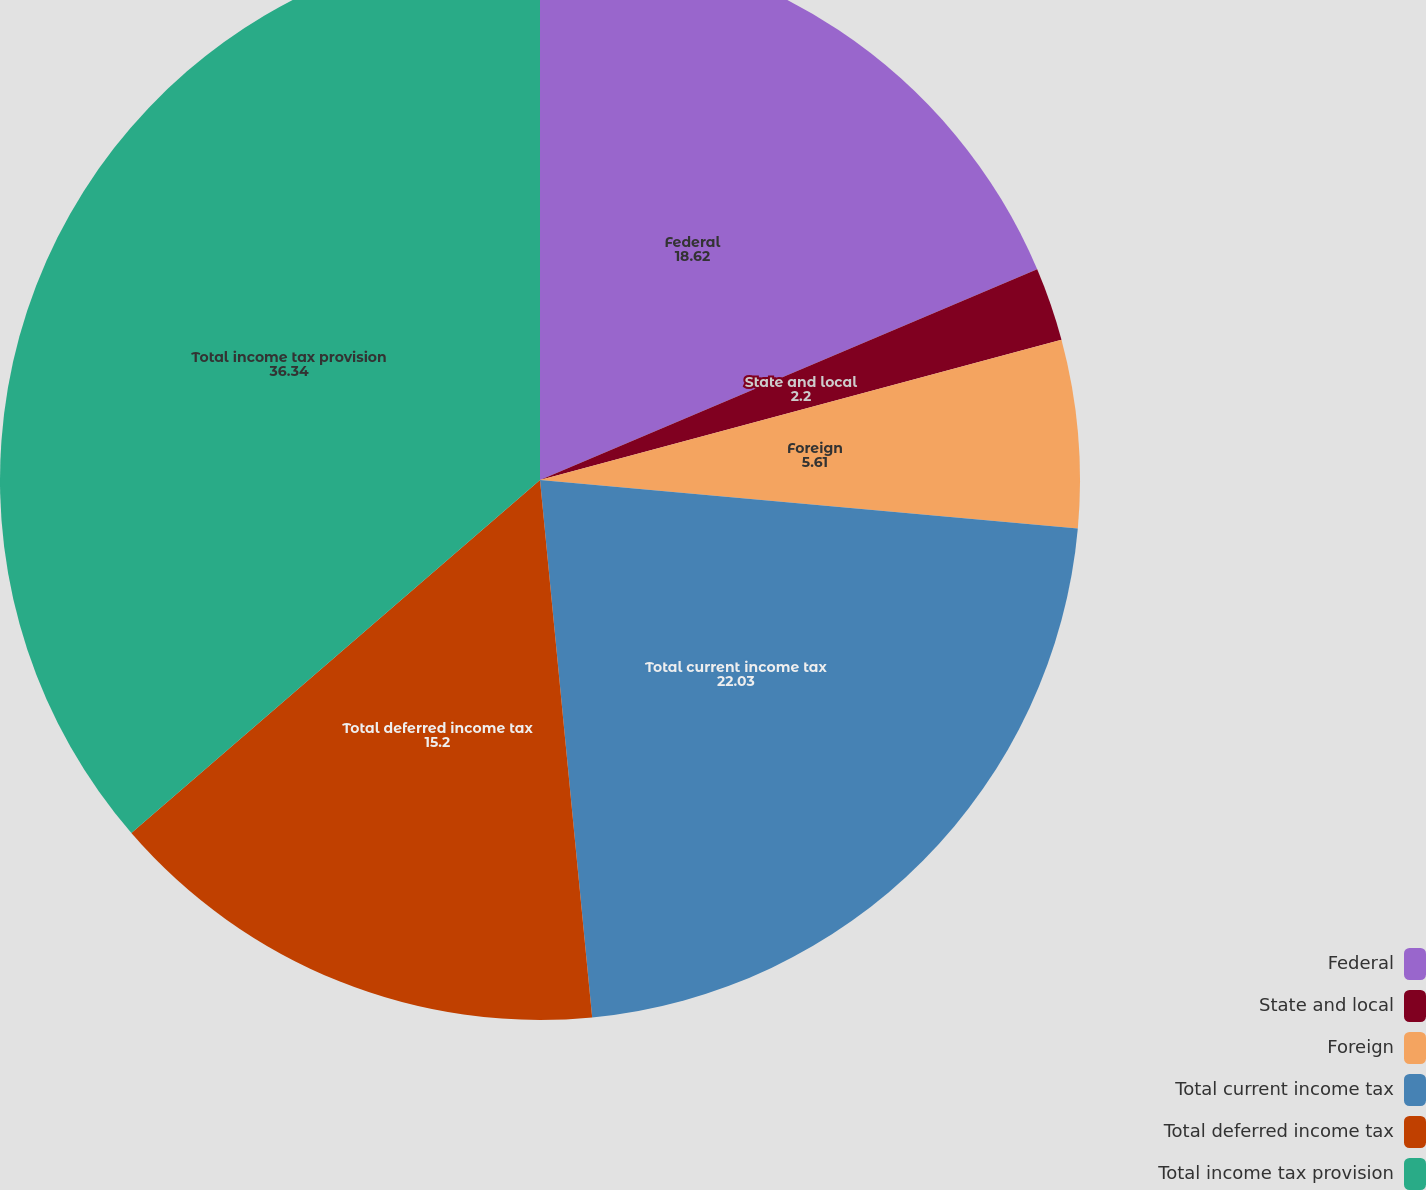Convert chart. <chart><loc_0><loc_0><loc_500><loc_500><pie_chart><fcel>Federal<fcel>State and local<fcel>Foreign<fcel>Total current income tax<fcel>Total deferred income tax<fcel>Total income tax provision<nl><fcel>18.62%<fcel>2.2%<fcel>5.61%<fcel>22.03%<fcel>15.2%<fcel>36.34%<nl></chart> 